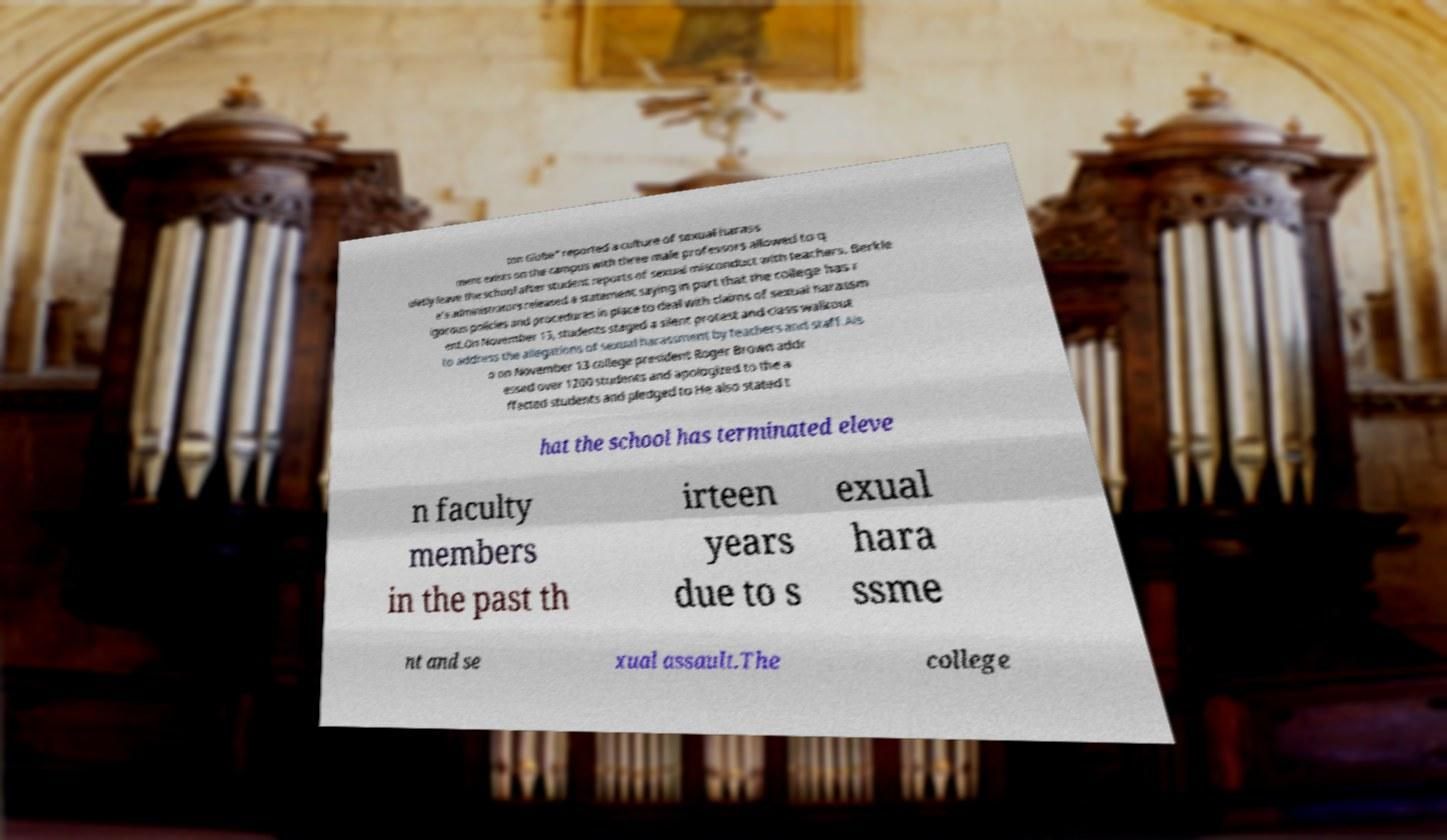Please identify and transcribe the text found in this image. ton Globe" reported a culture of sexual harass ment exists on the campus with three male professors allowed to q uietly leave the school after student reports of sexual misconduct with teachers. Berkle e's administrators released a statement saying in part that the college has r igorous policies and procedures in place to deal with claims of sexual harassm ent.On November 13, students staged a silent protest and class walkout to address the allegations of sexual harassment by teachers and staff.Als o on November 13 college president Roger Brown addr essed over 1200 students and apologized to the a ffected students and pledged to He also stated t hat the school has terminated eleve n faculty members in the past th irteen years due to s exual hara ssme nt and se xual assault.The college 